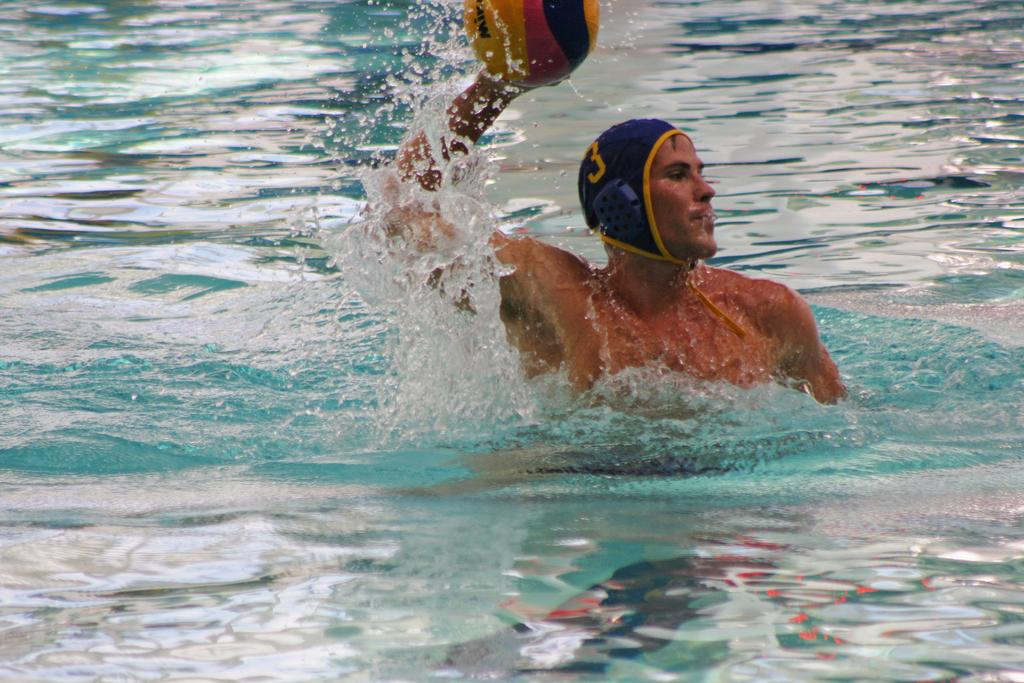Who is present in the image? There is a man in the image. What is the man holding in the image? The man is holding a ball. Where is the man's hand in the image? The man's hand is in the water. What type of food is the man eating out of his mouth in the image? There is no food or mouth visible in the image; the man's hand is in the water and he is holding a ball. 